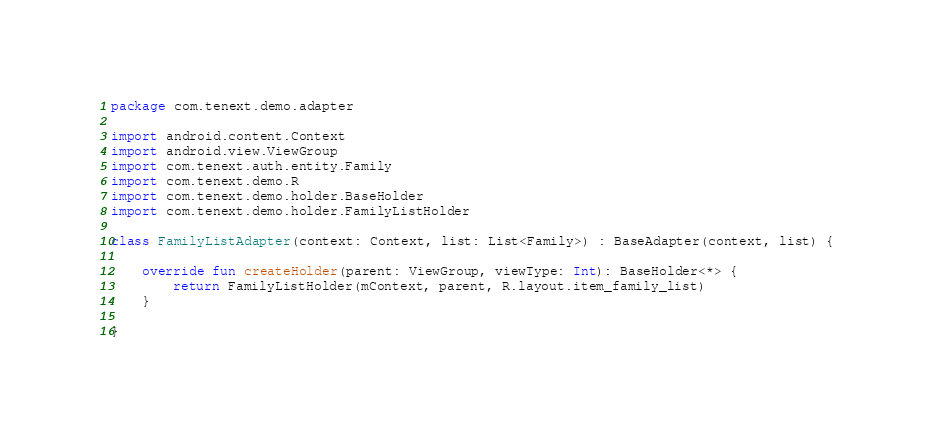Convert code to text. <code><loc_0><loc_0><loc_500><loc_500><_Kotlin_>package com.tenext.demo.adapter

import android.content.Context
import android.view.ViewGroup
import com.tenext.auth.entity.Family
import com.tenext.demo.R
import com.tenext.demo.holder.BaseHolder
import com.tenext.demo.holder.FamilyListHolder

class FamilyListAdapter(context: Context, list: List<Family>) : BaseAdapter(context, list) {

    override fun createHolder(parent: ViewGroup, viewType: Int): BaseHolder<*> {
        return FamilyListHolder(mContext, parent, R.layout.item_family_list)
    }

}</code> 